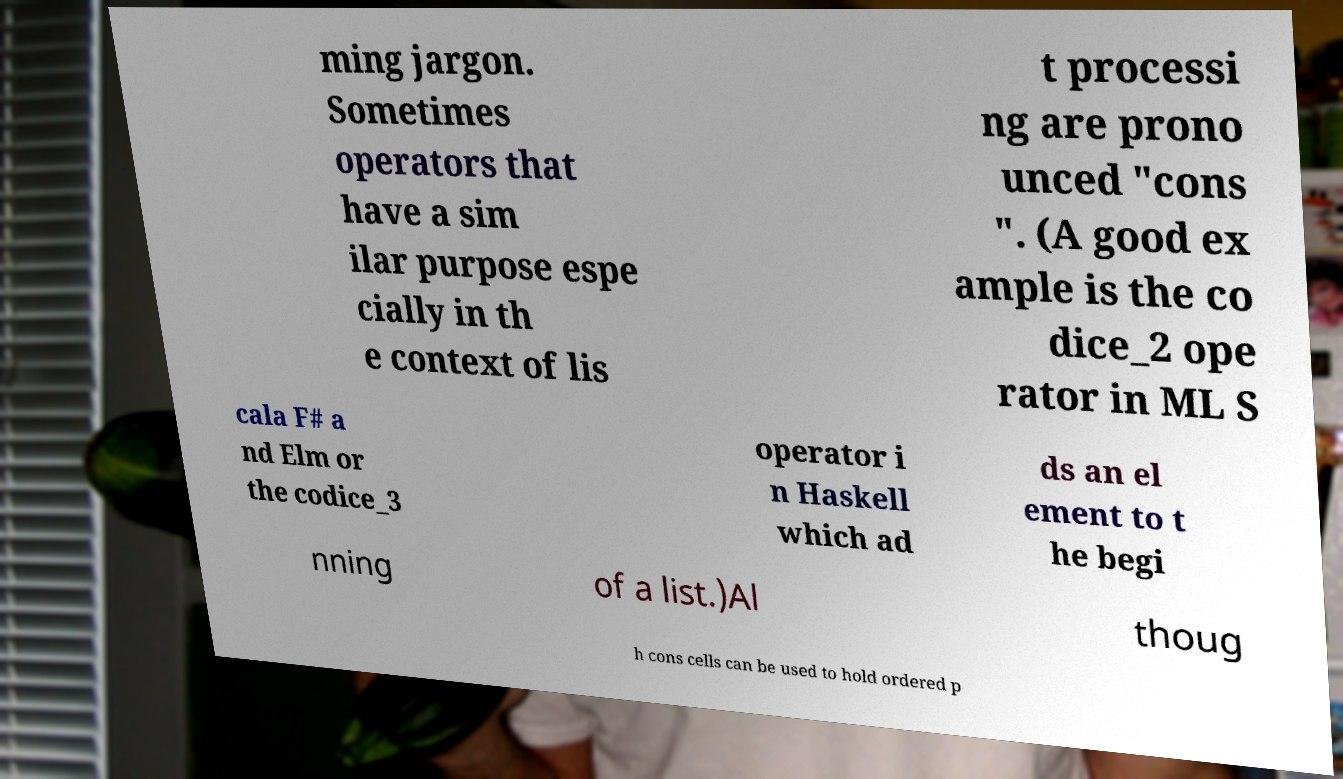Can you accurately transcribe the text from the provided image for me? ming jargon. Sometimes operators that have a sim ilar purpose espe cially in th e context of lis t processi ng are prono unced "cons ". (A good ex ample is the co dice_2 ope rator in ML S cala F# a nd Elm or the codice_3 operator i n Haskell which ad ds an el ement to t he begi nning of a list.)Al thoug h cons cells can be used to hold ordered p 